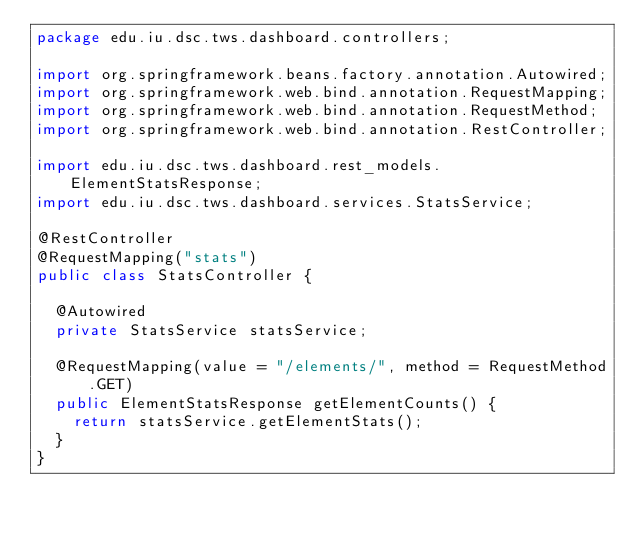<code> <loc_0><loc_0><loc_500><loc_500><_Java_>package edu.iu.dsc.tws.dashboard.controllers;

import org.springframework.beans.factory.annotation.Autowired;
import org.springframework.web.bind.annotation.RequestMapping;
import org.springframework.web.bind.annotation.RequestMethod;
import org.springframework.web.bind.annotation.RestController;

import edu.iu.dsc.tws.dashboard.rest_models.ElementStatsResponse;
import edu.iu.dsc.tws.dashboard.services.StatsService;

@RestController
@RequestMapping("stats")
public class StatsController {

  @Autowired
  private StatsService statsService;

  @RequestMapping(value = "/elements/", method = RequestMethod.GET)
  public ElementStatsResponse getElementCounts() {
    return statsService.getElementStats();
  }
}
</code> 